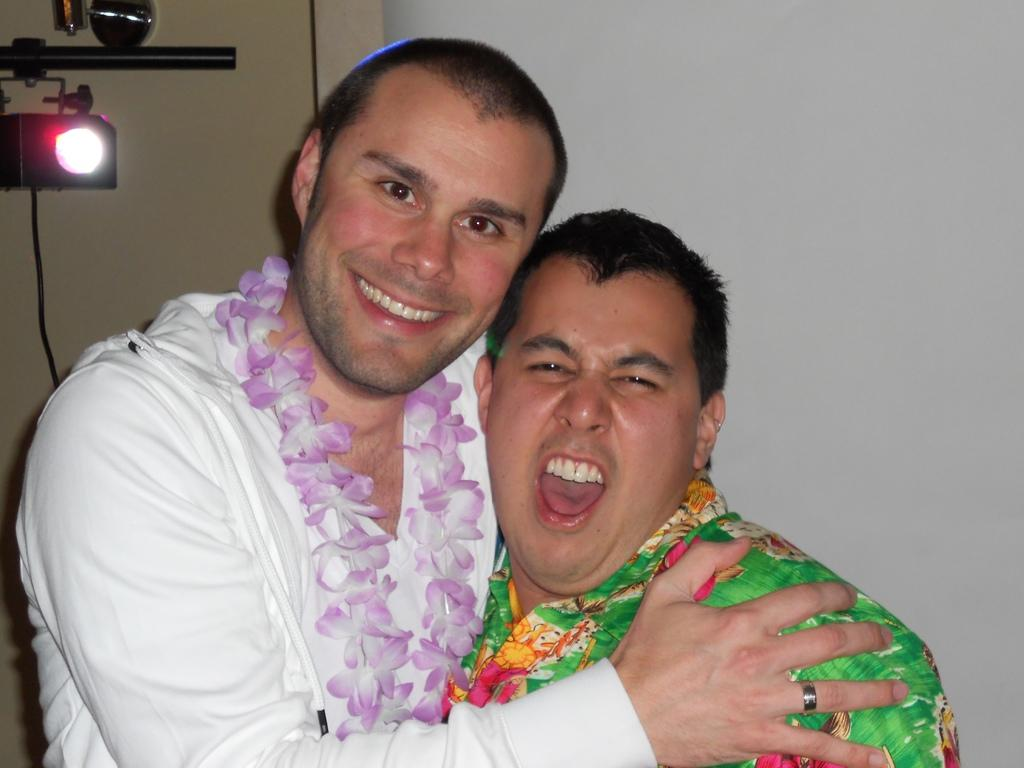What can be seen in the image? There are men standing in the image. What object is present in the image that is used for lighting? There is a light stand in the image. What architectural feature is visible in the background of the image? There is a door visible in the background of the image. What type of disease is being treated by the men in the image? The image does not show any men treating a disease; it only shows men standing and a light stand. 